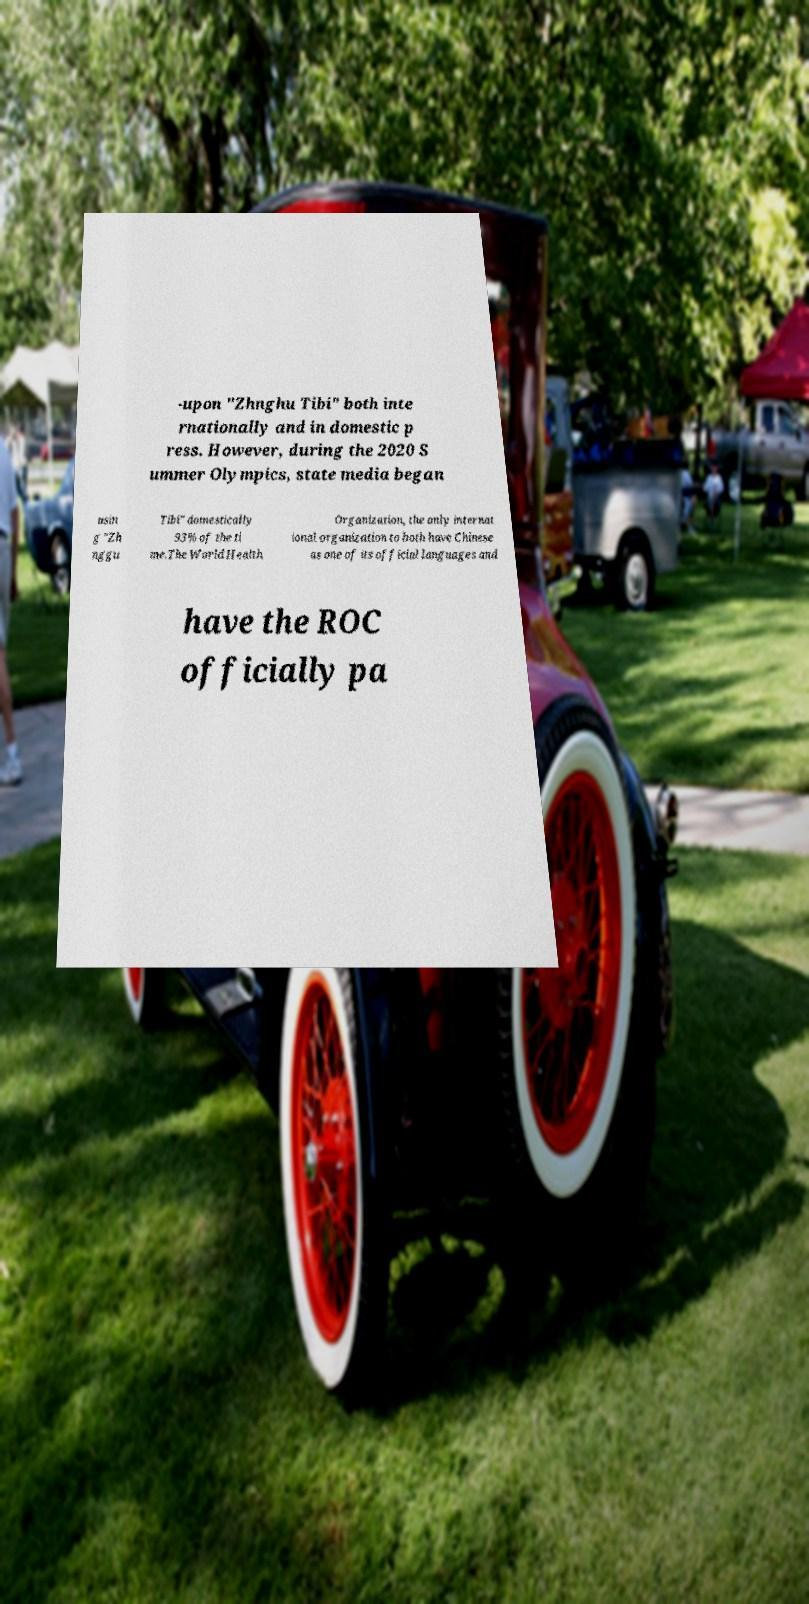Please identify and transcribe the text found in this image. -upon "Zhnghu Tibi" both inte rnationally and in domestic p ress. However, during the 2020 S ummer Olympics, state media began usin g "Zh nggu Tibi" domestically 93% of the ti me.The World Health Organization, the only internat ional organization to both have Chinese as one of its official languages and have the ROC officially pa 